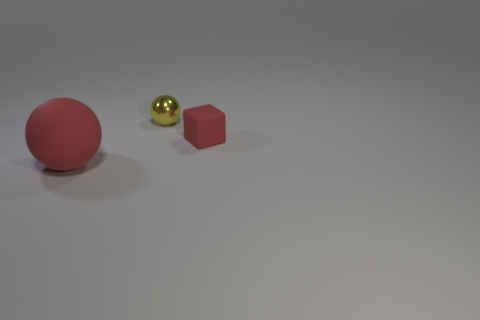Are the objects arranged in a particular pattern or alignment? The objects are spaced across the image plane, with no apparent pattern. However, their arrangement might suggest a subtle diagonal line that adds to the composition's visual flow. 